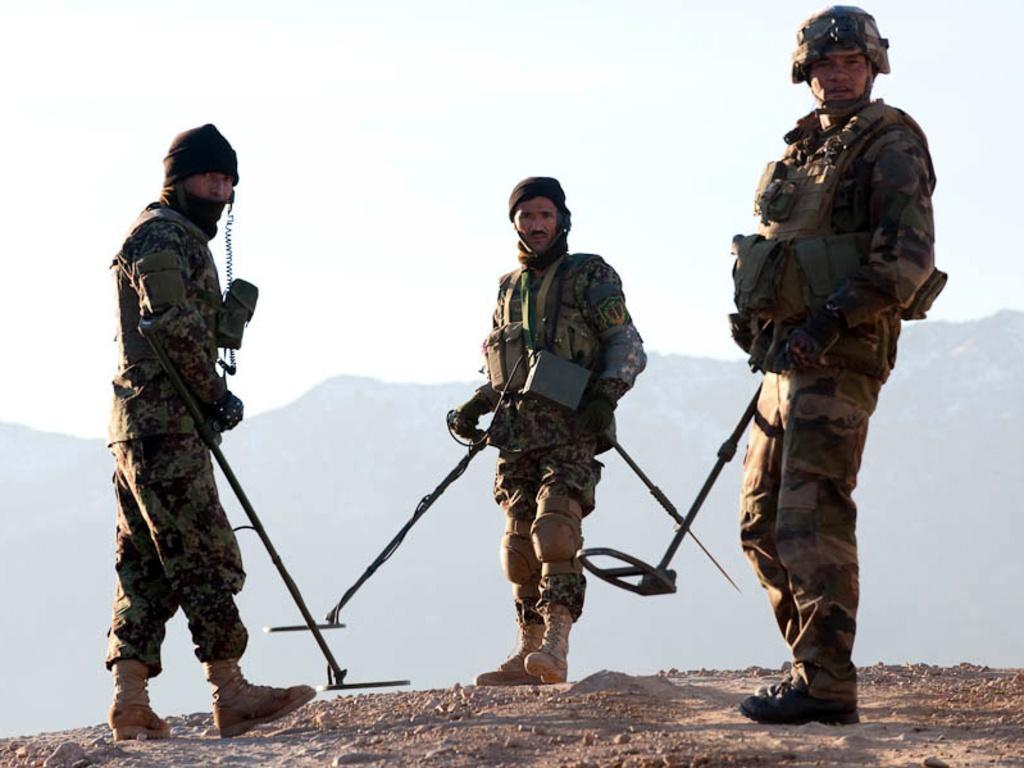Could you give a brief overview of what you see in this image? In this image we can see three person standing on the ground and holding some objects and there are mountains and the sky in the background. 